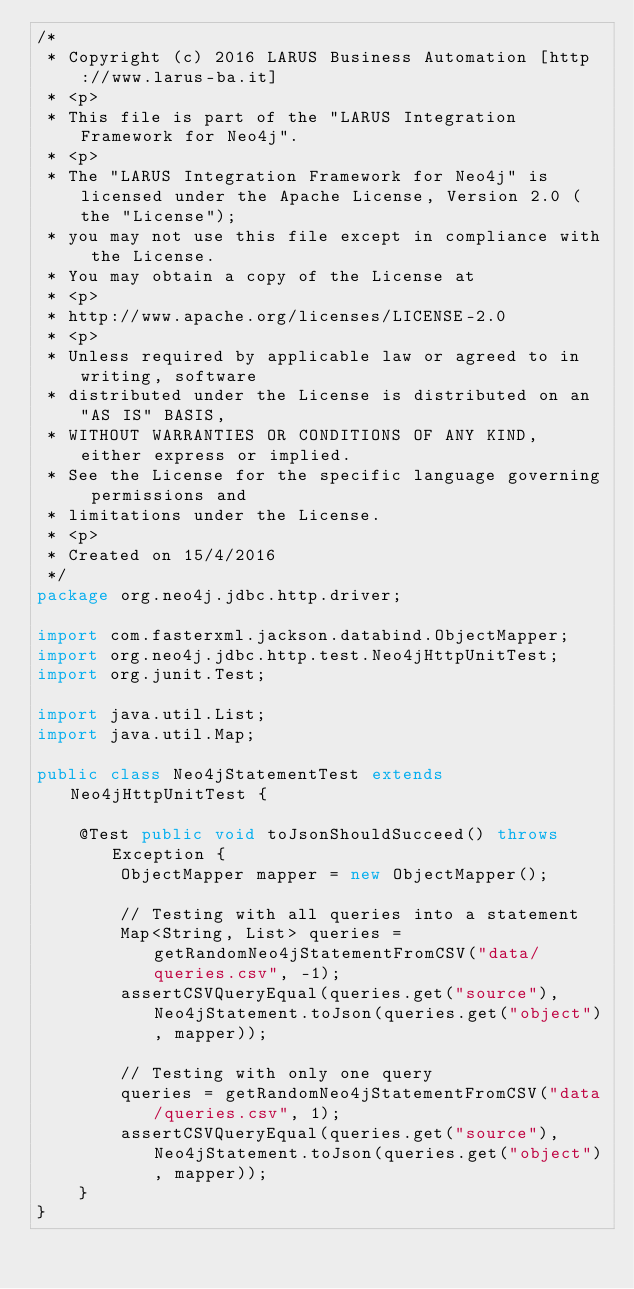Convert code to text. <code><loc_0><loc_0><loc_500><loc_500><_Java_>/*
 * Copyright (c) 2016 LARUS Business Automation [http://www.larus-ba.it]
 * <p>
 * This file is part of the "LARUS Integration Framework for Neo4j".
 * <p>
 * The "LARUS Integration Framework for Neo4j" is licensed under the Apache License, Version 2.0 (the "License");
 * you may not use this file except in compliance with the License.
 * You may obtain a copy of the License at
 * <p>
 * http://www.apache.org/licenses/LICENSE-2.0
 * <p>
 * Unless required by applicable law or agreed to in writing, software
 * distributed under the License is distributed on an "AS IS" BASIS,
 * WITHOUT WARRANTIES OR CONDITIONS OF ANY KIND, either express or implied.
 * See the License for the specific language governing permissions and
 * limitations under the License.
 * <p>
 * Created on 15/4/2016
 */
package org.neo4j.jdbc.http.driver;

import com.fasterxml.jackson.databind.ObjectMapper;
import org.neo4j.jdbc.http.test.Neo4jHttpUnitTest;
import org.junit.Test;

import java.util.List;
import java.util.Map;

public class Neo4jStatementTest extends Neo4jHttpUnitTest {

	@Test public void toJsonShouldSucceed() throws Exception {
		ObjectMapper mapper = new ObjectMapper();

		// Testing with all queries into a statement
		Map<String, List> queries = getRandomNeo4jStatementFromCSV("data/queries.csv", -1);
		assertCSVQueryEqual(queries.get("source"), Neo4jStatement.toJson(queries.get("object"), mapper));

		// Testing with only one query
		queries = getRandomNeo4jStatementFromCSV("data/queries.csv", 1);
		assertCSVQueryEqual(queries.get("source"), Neo4jStatement.toJson(queries.get("object"), mapper));
	}
}
</code> 